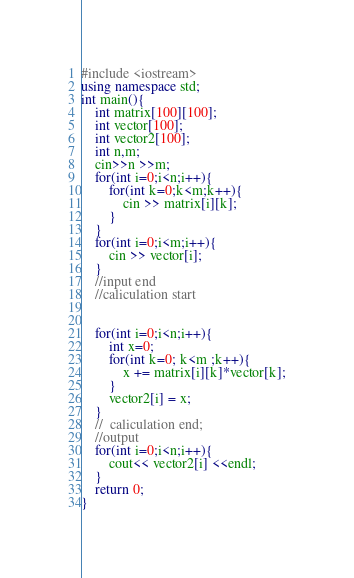<code> <loc_0><loc_0><loc_500><loc_500><_C++_>#include <iostream>
using namespace std;
int main(){
	int matrix[100][100];
	int vector[100];
	int vector2[100];
	int n,m;
	cin>>n >>m;
	for(int i=0;i<n;i++){
		for(int k=0;k<m;k++){
			cin >> matrix[i][k];
		}
	}
	for(int i=0;i<m;i++){
		cin >> vector[i];
	}
	//input end
	//caliculation start
	
	
	for(int i=0;i<n;i++){
		int x=0;
		for(int k=0; k<m ;k++){
			x += matrix[i][k]*vector[k];
		}
		vector2[i] = x;
	}
    //	caliculation end;
	//output
	for(int i=0;i<n;i++){
		cout<< vector2[i] <<endl;
	}
	return 0;
}</code> 